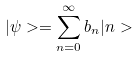<formula> <loc_0><loc_0><loc_500><loc_500>| \psi > = \sum _ { n = 0 } ^ { \infty } b _ { n } | n ></formula> 